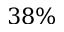Convert formula to latex. <formula><loc_0><loc_0><loc_500><loc_500>3 8 \%</formula> 